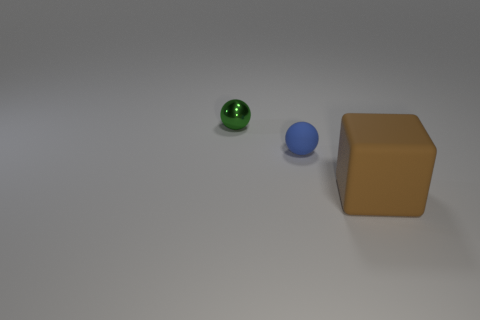Do the matte thing that is behind the brown matte object and the object behind the blue rubber sphere have the same shape?
Your answer should be very brief. Yes. Is there anything else that is the same shape as the brown matte thing?
Make the answer very short. No. What is the shape of the tiny object that is the same material as the big thing?
Give a very brief answer. Sphere. Are there an equal number of small shiny objects that are left of the green metal ball and matte cylinders?
Offer a very short reply. Yes. Do the small sphere that is behind the small matte ball and the tiny object that is to the right of the tiny green shiny sphere have the same material?
Provide a short and direct response. No. What shape is the rubber thing to the left of the object in front of the blue sphere?
Offer a very short reply. Sphere. The block that is the same material as the small blue thing is what color?
Make the answer very short. Brown. Is the rubber cube the same color as the tiny metallic object?
Your response must be concise. No. What is the shape of the other thing that is the same size as the blue thing?
Your answer should be very brief. Sphere. How big is the brown block?
Ensure brevity in your answer.  Large. 